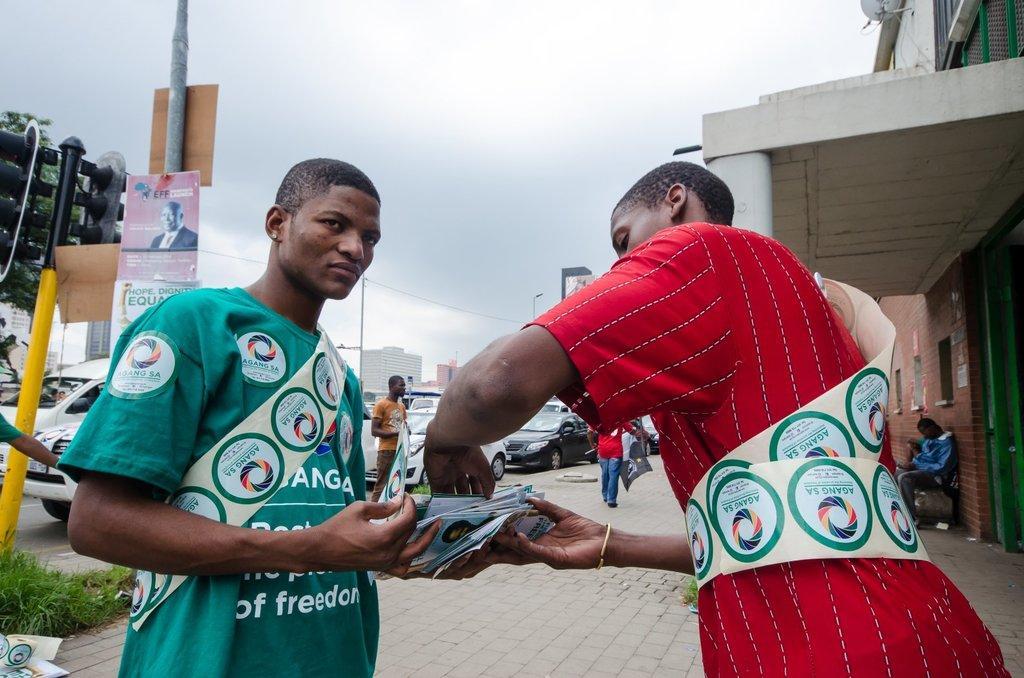How would you summarize this image in a sentence or two? In this image I can see few people with different color dresses and these people are holding the posters. To the right I can see the building. To the left there are boards and poles and there are many vehicles on the road. I can also see the grass to the left. In the background there are few more buildings and the sky. 